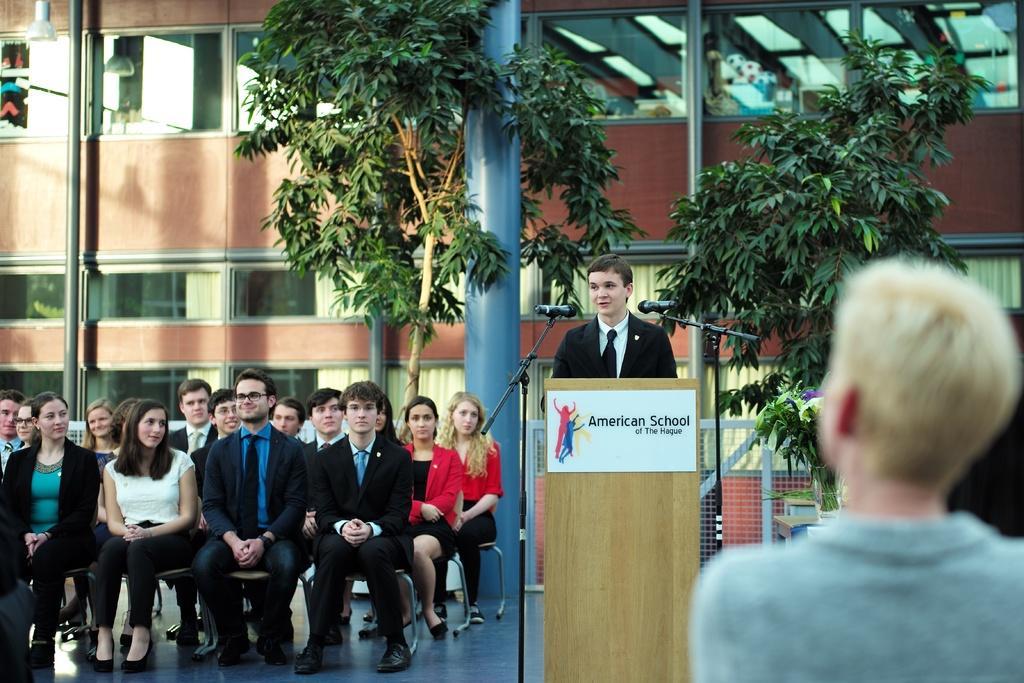Describe this image in one or two sentences. In this picture we can see chairs on the floor with a group of people sitting on it, podium with a poster on it, mics and two people. In the background we can see a pillar, fence, building, trees and some objects. 